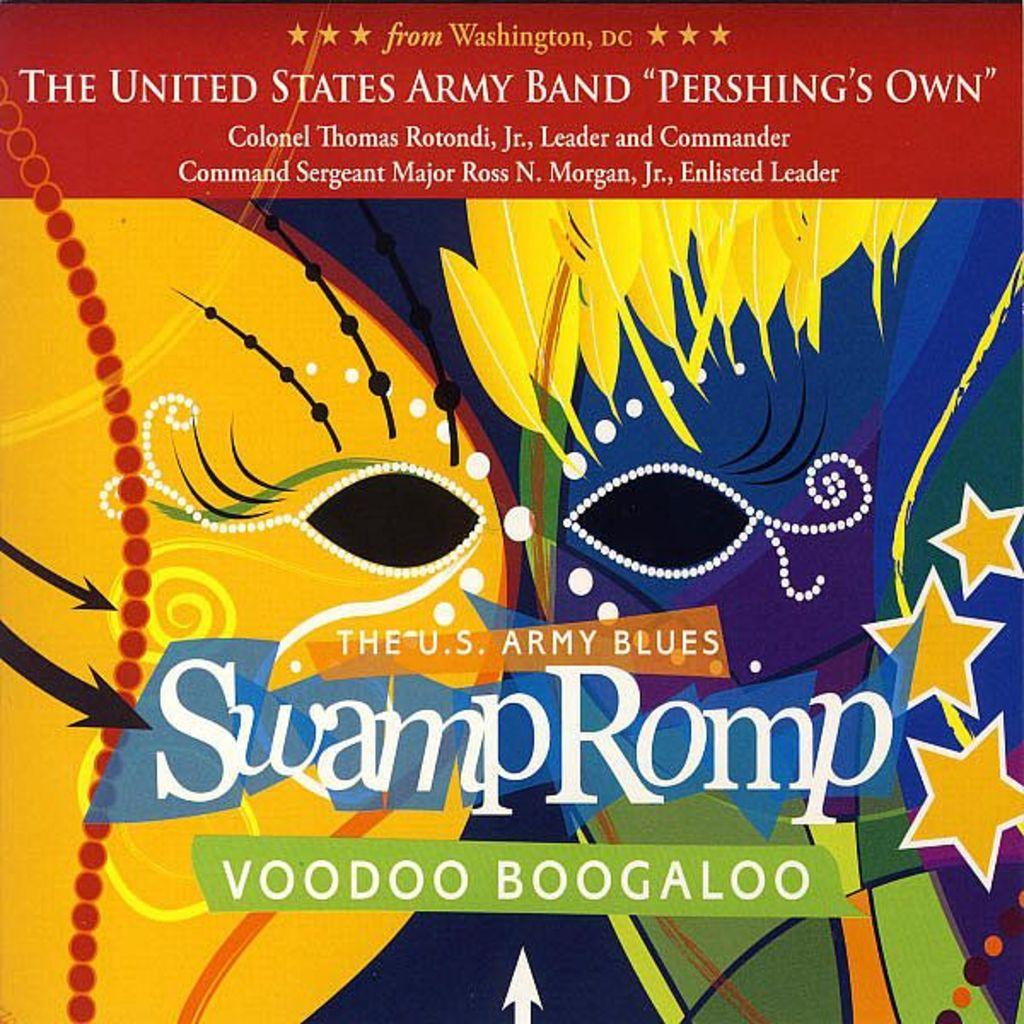<image>
Offer a succinct explanation of the picture presented. A colorful poster for The U.S. Army Blues Swamp Romp Voodoo Boogaloo. 